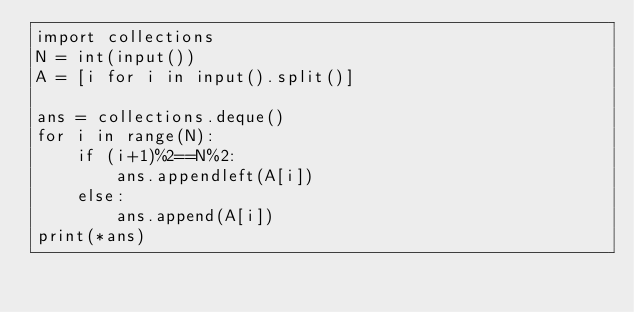Convert code to text. <code><loc_0><loc_0><loc_500><loc_500><_Python_>import collections
N = int(input())
A = [i for i in input().split()]

ans = collections.deque()
for i in range(N):
    if (i+1)%2==N%2:
        ans.appendleft(A[i])
    else:
        ans.append(A[i])
print(*ans)</code> 